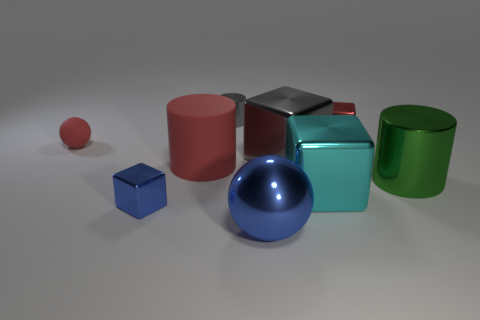Is there a metal thing that has the same color as the tiny ball?
Make the answer very short. Yes. What is the material of the cylinder that is the same color as the tiny matte ball?
Ensure brevity in your answer.  Rubber. Is the tiny sphere the same color as the big matte cylinder?
Your answer should be compact. Yes. The large cyan object has what shape?
Offer a very short reply. Cube. What shape is the gray object that is the same size as the green metal thing?
Offer a terse response. Cube. Is there anything else of the same color as the large matte cylinder?
Give a very brief answer. Yes. There is a blue sphere that is the same material as the tiny gray cylinder; what is its size?
Provide a succinct answer. Large. Do the tiny red metallic thing and the gray shiny object that is to the right of the small gray metallic object have the same shape?
Provide a succinct answer. Yes. The blue metallic cube has what size?
Provide a short and direct response. Small. Is the number of rubber things that are on the left side of the tiny matte object less than the number of large objects?
Give a very brief answer. Yes. 